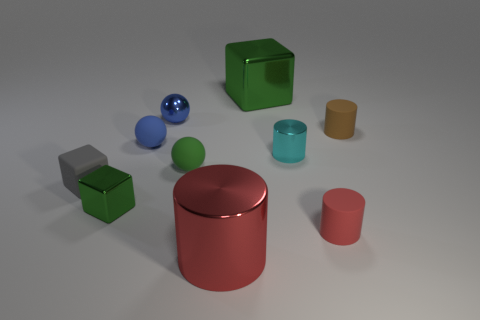Subtract all yellow cylinders. Subtract all red blocks. How many cylinders are left? 4 Subtract all balls. How many objects are left? 7 Add 4 small red objects. How many small red objects exist? 5 Subtract 0 gray balls. How many objects are left? 10 Subtract all green metallic things. Subtract all small green spheres. How many objects are left? 7 Add 3 small shiny cylinders. How many small shiny cylinders are left? 4 